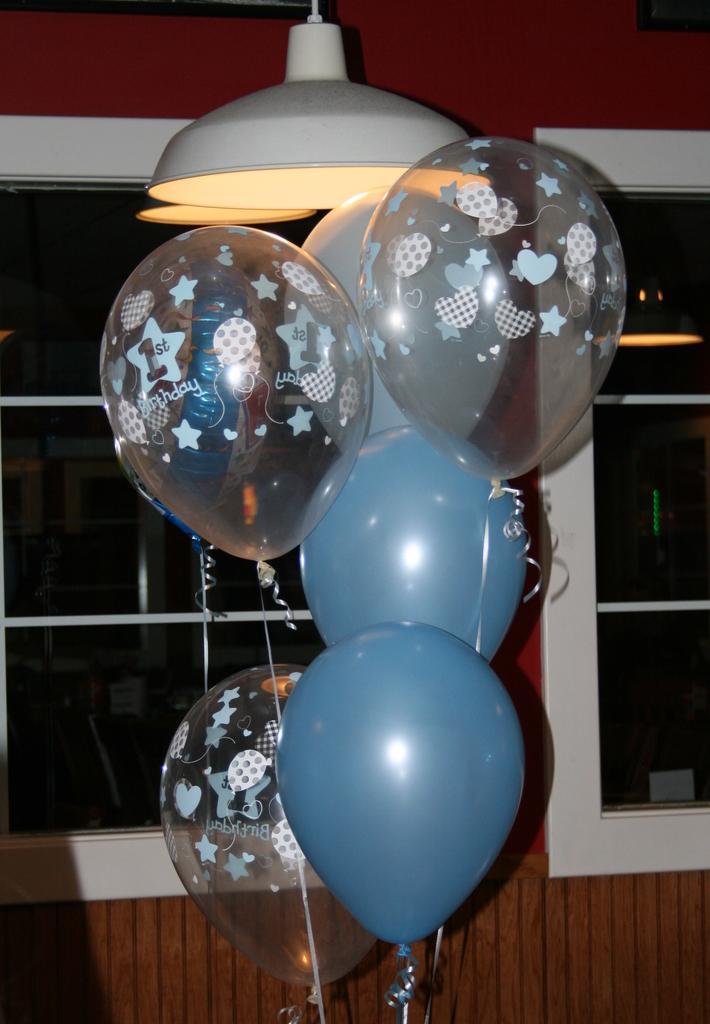How would you summarize this image in a sentence or two? In the center of the image balloons, lamps are there. In the background of the image windows, wall are present. 